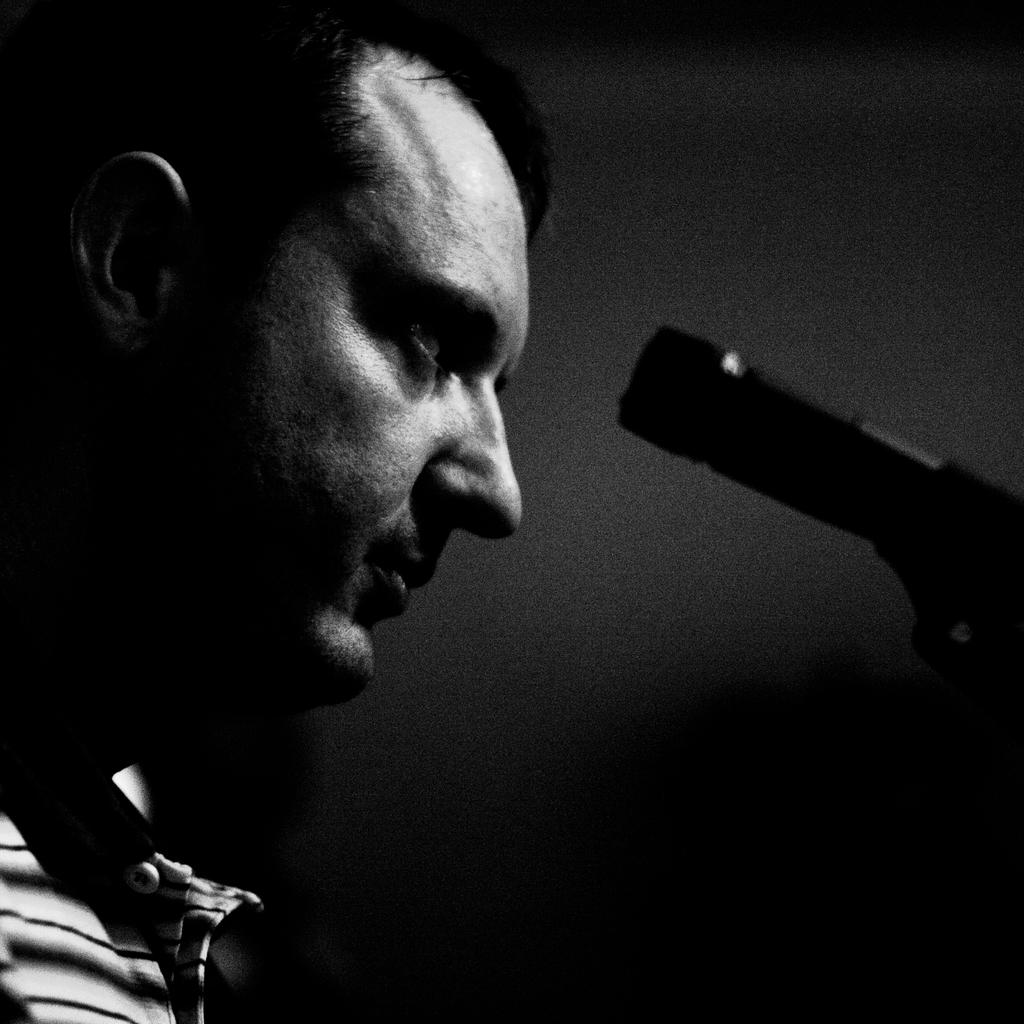What is the color scheme of the image? The image is black and white. Can you describe the main subject in the image? There is a man in the image. What object is present in the image that is typically used for amplifying sound? There is a microphone (mic) in the image. What type of floor can be seen in the image? There is no floor visible in the image, as it is a black and white image featuring a man and a microphone. Can you describe the monkey's behavior in the image? There is no monkey present in the image. 